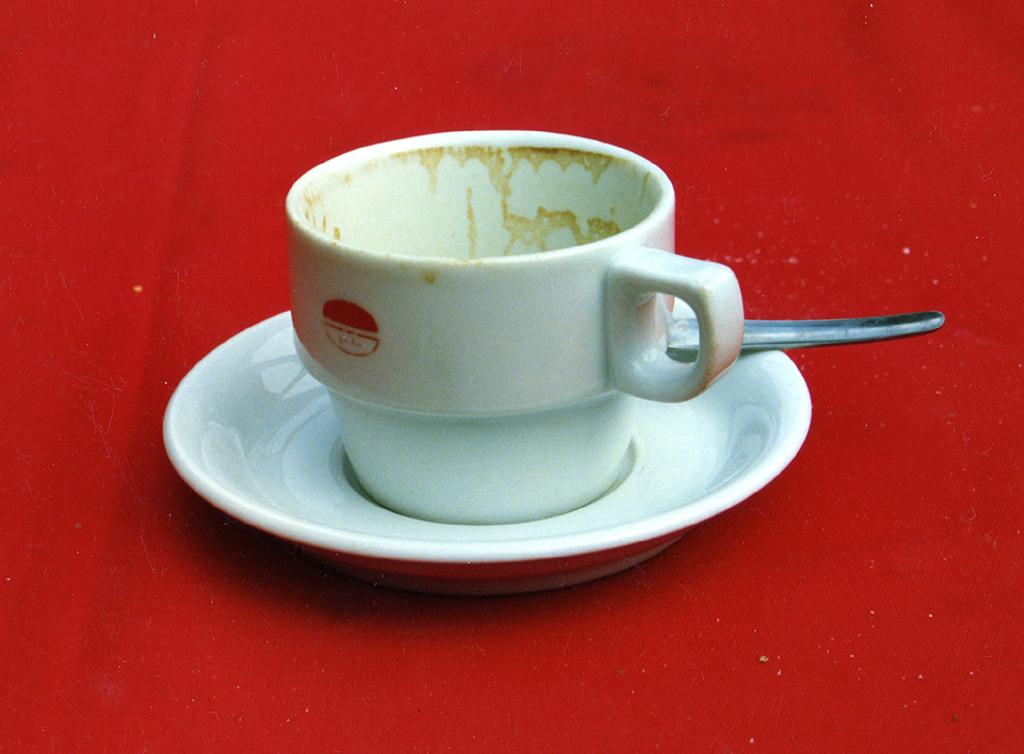What is present on the red cloth in the image? There is a cup and a saucer placed on the red cloth. What is the color of the cloth in the image? The cloth is red. What time is displayed on the clocks in the image? There are no clocks present in the image; it only features a cup and saucer placed on a red cloth. 